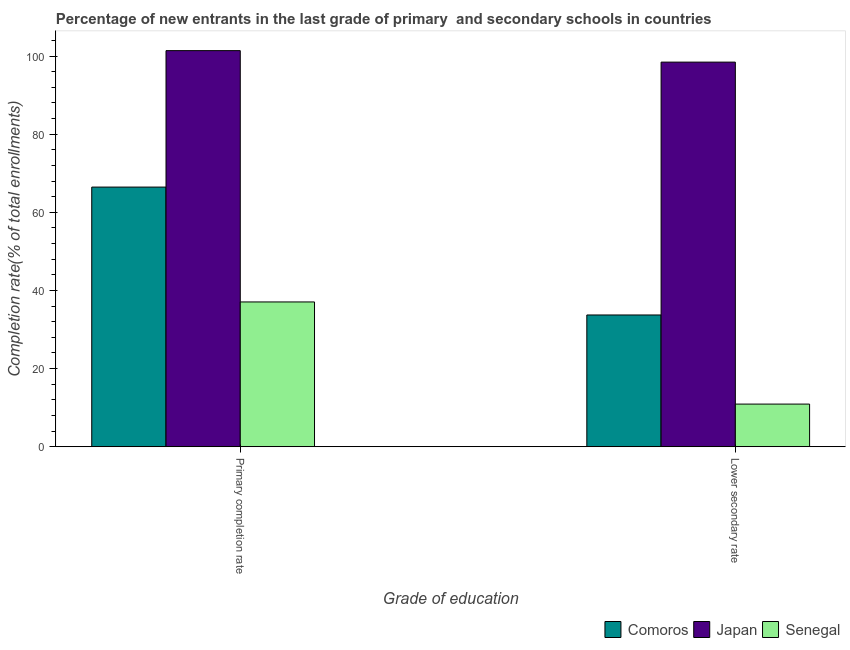How many different coloured bars are there?
Offer a very short reply. 3. How many groups of bars are there?
Your answer should be compact. 2. Are the number of bars per tick equal to the number of legend labels?
Keep it short and to the point. Yes. How many bars are there on the 1st tick from the left?
Make the answer very short. 3. How many bars are there on the 1st tick from the right?
Offer a terse response. 3. What is the label of the 2nd group of bars from the left?
Your response must be concise. Lower secondary rate. What is the completion rate in secondary schools in Japan?
Offer a terse response. 98.44. Across all countries, what is the maximum completion rate in secondary schools?
Give a very brief answer. 98.44. Across all countries, what is the minimum completion rate in secondary schools?
Make the answer very short. 10.92. In which country was the completion rate in primary schools minimum?
Make the answer very short. Senegal. What is the total completion rate in secondary schools in the graph?
Your answer should be compact. 143.08. What is the difference between the completion rate in primary schools in Japan and that in Comoros?
Provide a succinct answer. 34.93. What is the difference between the completion rate in secondary schools in Comoros and the completion rate in primary schools in Japan?
Provide a succinct answer. -67.66. What is the average completion rate in secondary schools per country?
Your answer should be compact. 47.69. What is the difference between the completion rate in primary schools and completion rate in secondary schools in Japan?
Ensure brevity in your answer.  2.94. What is the ratio of the completion rate in primary schools in Comoros to that in Senegal?
Offer a very short reply. 1.79. Is the completion rate in secondary schools in Japan less than that in Comoros?
Give a very brief answer. No. In how many countries, is the completion rate in primary schools greater than the average completion rate in primary schools taken over all countries?
Your response must be concise. 1. What does the 1st bar from the left in Lower secondary rate represents?
Offer a very short reply. Comoros. What does the 2nd bar from the right in Primary completion rate represents?
Your answer should be compact. Japan. Are all the bars in the graph horizontal?
Give a very brief answer. No. How many countries are there in the graph?
Provide a succinct answer. 3. How are the legend labels stacked?
Your answer should be compact. Horizontal. What is the title of the graph?
Provide a succinct answer. Percentage of new entrants in the last grade of primary  and secondary schools in countries. Does "Israel" appear as one of the legend labels in the graph?
Provide a short and direct response. No. What is the label or title of the X-axis?
Give a very brief answer. Grade of education. What is the label or title of the Y-axis?
Make the answer very short. Completion rate(% of total enrollments). What is the Completion rate(% of total enrollments) of Comoros in Primary completion rate?
Ensure brevity in your answer.  66.46. What is the Completion rate(% of total enrollments) in Japan in Primary completion rate?
Provide a short and direct response. 101.38. What is the Completion rate(% of total enrollments) of Senegal in Primary completion rate?
Provide a short and direct response. 37.06. What is the Completion rate(% of total enrollments) in Comoros in Lower secondary rate?
Give a very brief answer. 33.72. What is the Completion rate(% of total enrollments) of Japan in Lower secondary rate?
Provide a succinct answer. 98.44. What is the Completion rate(% of total enrollments) of Senegal in Lower secondary rate?
Give a very brief answer. 10.92. Across all Grade of education, what is the maximum Completion rate(% of total enrollments) in Comoros?
Offer a terse response. 66.46. Across all Grade of education, what is the maximum Completion rate(% of total enrollments) of Japan?
Provide a succinct answer. 101.38. Across all Grade of education, what is the maximum Completion rate(% of total enrollments) of Senegal?
Your response must be concise. 37.06. Across all Grade of education, what is the minimum Completion rate(% of total enrollments) of Comoros?
Keep it short and to the point. 33.72. Across all Grade of education, what is the minimum Completion rate(% of total enrollments) in Japan?
Keep it short and to the point. 98.44. Across all Grade of education, what is the minimum Completion rate(% of total enrollments) of Senegal?
Keep it short and to the point. 10.92. What is the total Completion rate(% of total enrollments) in Comoros in the graph?
Provide a succinct answer. 100.18. What is the total Completion rate(% of total enrollments) in Japan in the graph?
Ensure brevity in your answer.  199.83. What is the total Completion rate(% of total enrollments) in Senegal in the graph?
Ensure brevity in your answer.  47.97. What is the difference between the Completion rate(% of total enrollments) in Comoros in Primary completion rate and that in Lower secondary rate?
Your answer should be compact. 32.74. What is the difference between the Completion rate(% of total enrollments) of Japan in Primary completion rate and that in Lower secondary rate?
Offer a very short reply. 2.94. What is the difference between the Completion rate(% of total enrollments) in Senegal in Primary completion rate and that in Lower secondary rate?
Your answer should be compact. 26.14. What is the difference between the Completion rate(% of total enrollments) in Comoros in Primary completion rate and the Completion rate(% of total enrollments) in Japan in Lower secondary rate?
Your answer should be very brief. -31.99. What is the difference between the Completion rate(% of total enrollments) of Comoros in Primary completion rate and the Completion rate(% of total enrollments) of Senegal in Lower secondary rate?
Keep it short and to the point. 55.54. What is the difference between the Completion rate(% of total enrollments) in Japan in Primary completion rate and the Completion rate(% of total enrollments) in Senegal in Lower secondary rate?
Your answer should be very brief. 90.47. What is the average Completion rate(% of total enrollments) in Comoros per Grade of education?
Your response must be concise. 50.09. What is the average Completion rate(% of total enrollments) in Japan per Grade of education?
Your response must be concise. 99.91. What is the average Completion rate(% of total enrollments) of Senegal per Grade of education?
Offer a terse response. 23.99. What is the difference between the Completion rate(% of total enrollments) in Comoros and Completion rate(% of total enrollments) in Japan in Primary completion rate?
Keep it short and to the point. -34.93. What is the difference between the Completion rate(% of total enrollments) of Comoros and Completion rate(% of total enrollments) of Senegal in Primary completion rate?
Your response must be concise. 29.4. What is the difference between the Completion rate(% of total enrollments) of Japan and Completion rate(% of total enrollments) of Senegal in Primary completion rate?
Offer a terse response. 64.33. What is the difference between the Completion rate(% of total enrollments) of Comoros and Completion rate(% of total enrollments) of Japan in Lower secondary rate?
Offer a terse response. -64.72. What is the difference between the Completion rate(% of total enrollments) of Comoros and Completion rate(% of total enrollments) of Senegal in Lower secondary rate?
Ensure brevity in your answer.  22.8. What is the difference between the Completion rate(% of total enrollments) in Japan and Completion rate(% of total enrollments) in Senegal in Lower secondary rate?
Provide a succinct answer. 87.53. What is the ratio of the Completion rate(% of total enrollments) in Comoros in Primary completion rate to that in Lower secondary rate?
Your answer should be compact. 1.97. What is the ratio of the Completion rate(% of total enrollments) of Japan in Primary completion rate to that in Lower secondary rate?
Give a very brief answer. 1.03. What is the ratio of the Completion rate(% of total enrollments) of Senegal in Primary completion rate to that in Lower secondary rate?
Offer a very short reply. 3.39. What is the difference between the highest and the second highest Completion rate(% of total enrollments) of Comoros?
Offer a very short reply. 32.74. What is the difference between the highest and the second highest Completion rate(% of total enrollments) of Japan?
Your answer should be compact. 2.94. What is the difference between the highest and the second highest Completion rate(% of total enrollments) of Senegal?
Ensure brevity in your answer.  26.14. What is the difference between the highest and the lowest Completion rate(% of total enrollments) of Comoros?
Ensure brevity in your answer.  32.74. What is the difference between the highest and the lowest Completion rate(% of total enrollments) of Japan?
Give a very brief answer. 2.94. What is the difference between the highest and the lowest Completion rate(% of total enrollments) in Senegal?
Make the answer very short. 26.14. 